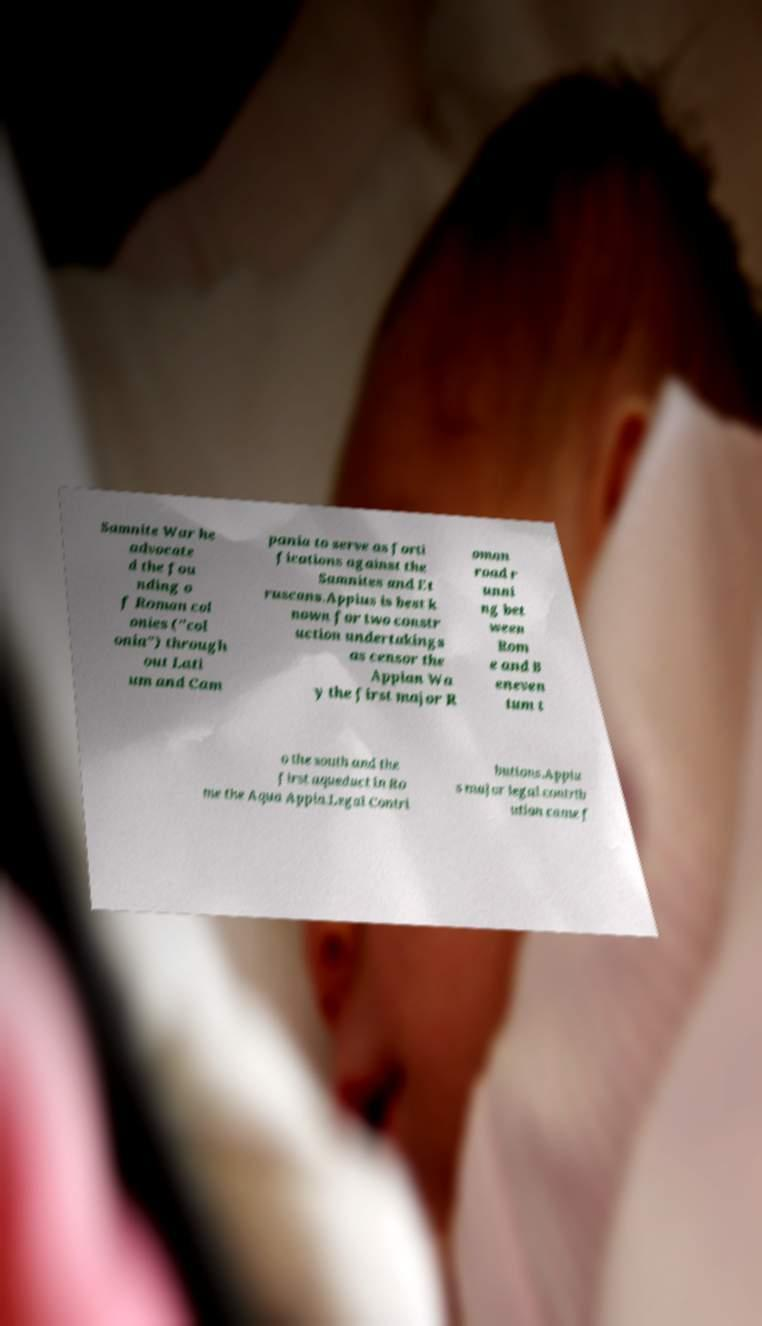Can you accurately transcribe the text from the provided image for me? Samnite War he advocate d the fou nding o f Roman col onies ("col onia") through out Lati um and Cam pania to serve as forti fications against the Samnites and Et ruscans.Appius is best k nown for two constr uction undertakings as censor the Appian Wa y the first major R oman road r unni ng bet ween Rom e and B eneven tum t o the south and the first aqueduct in Ro me the Aqua Appia.Legal Contri butions.Appiu s major legal contrib ution came f 